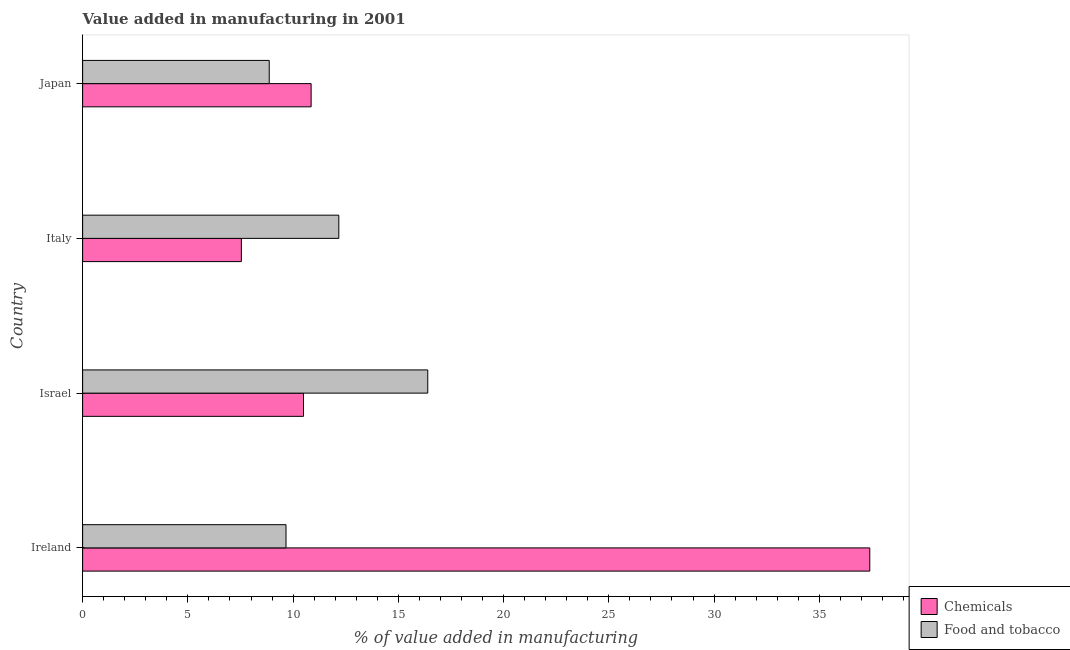How many different coloured bars are there?
Keep it short and to the point. 2. Are the number of bars per tick equal to the number of legend labels?
Your response must be concise. Yes. Are the number of bars on each tick of the Y-axis equal?
Keep it short and to the point. Yes. What is the label of the 1st group of bars from the top?
Provide a short and direct response. Japan. In how many cases, is the number of bars for a given country not equal to the number of legend labels?
Offer a very short reply. 0. What is the value added by  manufacturing chemicals in Ireland?
Ensure brevity in your answer.  37.4. Across all countries, what is the maximum value added by manufacturing food and tobacco?
Offer a terse response. 16.4. Across all countries, what is the minimum value added by manufacturing food and tobacco?
Make the answer very short. 8.87. What is the total value added by  manufacturing chemicals in the graph?
Provide a succinct answer. 66.29. What is the difference between the value added by  manufacturing chemicals in Ireland and that in Israel?
Provide a succinct answer. 26.9. What is the difference between the value added by manufacturing food and tobacco in Japan and the value added by  manufacturing chemicals in Italy?
Keep it short and to the point. 1.32. What is the average value added by  manufacturing chemicals per country?
Offer a very short reply. 16.57. What is the difference between the value added by  manufacturing chemicals and value added by manufacturing food and tobacco in Ireland?
Your answer should be compact. 27.73. In how many countries, is the value added by  manufacturing chemicals greater than 8 %?
Provide a short and direct response. 3. What is the ratio of the value added by  manufacturing chemicals in Ireland to that in Israel?
Ensure brevity in your answer.  3.56. Is the value added by  manufacturing chemicals in Ireland less than that in Japan?
Give a very brief answer. No. What is the difference between the highest and the second highest value added by manufacturing food and tobacco?
Give a very brief answer. 4.23. What is the difference between the highest and the lowest value added by manufacturing food and tobacco?
Provide a short and direct response. 7.53. In how many countries, is the value added by  manufacturing chemicals greater than the average value added by  manufacturing chemicals taken over all countries?
Make the answer very short. 1. What does the 2nd bar from the top in Italy represents?
Offer a terse response. Chemicals. What does the 1st bar from the bottom in Italy represents?
Your answer should be very brief. Chemicals. Are all the bars in the graph horizontal?
Ensure brevity in your answer.  Yes. How many countries are there in the graph?
Keep it short and to the point. 4. Are the values on the major ticks of X-axis written in scientific E-notation?
Offer a terse response. No. How many legend labels are there?
Your answer should be compact. 2. What is the title of the graph?
Your answer should be very brief. Value added in manufacturing in 2001. Does "Female labor force" appear as one of the legend labels in the graph?
Your answer should be compact. No. What is the label or title of the X-axis?
Make the answer very short. % of value added in manufacturing. What is the label or title of the Y-axis?
Offer a terse response. Country. What is the % of value added in manufacturing in Chemicals in Ireland?
Provide a succinct answer. 37.4. What is the % of value added in manufacturing of Food and tobacco in Ireland?
Provide a succinct answer. 9.66. What is the % of value added in manufacturing of Chemicals in Israel?
Keep it short and to the point. 10.49. What is the % of value added in manufacturing of Food and tobacco in Israel?
Offer a very short reply. 16.4. What is the % of value added in manufacturing of Chemicals in Italy?
Your answer should be very brief. 7.54. What is the % of value added in manufacturing of Food and tobacco in Italy?
Ensure brevity in your answer.  12.17. What is the % of value added in manufacturing of Chemicals in Japan?
Your answer should be very brief. 10.86. What is the % of value added in manufacturing of Food and tobacco in Japan?
Provide a succinct answer. 8.87. Across all countries, what is the maximum % of value added in manufacturing in Chemicals?
Give a very brief answer. 37.4. Across all countries, what is the maximum % of value added in manufacturing of Food and tobacco?
Ensure brevity in your answer.  16.4. Across all countries, what is the minimum % of value added in manufacturing in Chemicals?
Provide a short and direct response. 7.54. Across all countries, what is the minimum % of value added in manufacturing of Food and tobacco?
Ensure brevity in your answer.  8.87. What is the total % of value added in manufacturing in Chemicals in the graph?
Provide a short and direct response. 66.29. What is the total % of value added in manufacturing of Food and tobacco in the graph?
Provide a succinct answer. 47.1. What is the difference between the % of value added in manufacturing in Chemicals in Ireland and that in Israel?
Offer a very short reply. 26.9. What is the difference between the % of value added in manufacturing of Food and tobacco in Ireland and that in Israel?
Keep it short and to the point. -6.73. What is the difference between the % of value added in manufacturing of Chemicals in Ireland and that in Italy?
Ensure brevity in your answer.  29.86. What is the difference between the % of value added in manufacturing of Food and tobacco in Ireland and that in Italy?
Provide a short and direct response. -2.51. What is the difference between the % of value added in manufacturing of Chemicals in Ireland and that in Japan?
Provide a succinct answer. 26.54. What is the difference between the % of value added in manufacturing in Food and tobacco in Ireland and that in Japan?
Give a very brief answer. 0.8. What is the difference between the % of value added in manufacturing of Chemicals in Israel and that in Italy?
Offer a terse response. 2.95. What is the difference between the % of value added in manufacturing of Food and tobacco in Israel and that in Italy?
Offer a terse response. 4.23. What is the difference between the % of value added in manufacturing of Chemicals in Israel and that in Japan?
Offer a terse response. -0.36. What is the difference between the % of value added in manufacturing in Food and tobacco in Israel and that in Japan?
Give a very brief answer. 7.53. What is the difference between the % of value added in manufacturing of Chemicals in Italy and that in Japan?
Keep it short and to the point. -3.32. What is the difference between the % of value added in manufacturing of Food and tobacco in Italy and that in Japan?
Give a very brief answer. 3.31. What is the difference between the % of value added in manufacturing of Chemicals in Ireland and the % of value added in manufacturing of Food and tobacco in Israel?
Your answer should be very brief. 21. What is the difference between the % of value added in manufacturing of Chemicals in Ireland and the % of value added in manufacturing of Food and tobacco in Italy?
Your response must be concise. 25.23. What is the difference between the % of value added in manufacturing in Chemicals in Ireland and the % of value added in manufacturing in Food and tobacco in Japan?
Your answer should be very brief. 28.53. What is the difference between the % of value added in manufacturing of Chemicals in Israel and the % of value added in manufacturing of Food and tobacco in Italy?
Keep it short and to the point. -1.68. What is the difference between the % of value added in manufacturing in Chemicals in Israel and the % of value added in manufacturing in Food and tobacco in Japan?
Offer a very short reply. 1.63. What is the difference between the % of value added in manufacturing in Chemicals in Italy and the % of value added in manufacturing in Food and tobacco in Japan?
Give a very brief answer. -1.32. What is the average % of value added in manufacturing in Chemicals per country?
Your answer should be very brief. 16.57. What is the average % of value added in manufacturing of Food and tobacco per country?
Your answer should be compact. 11.77. What is the difference between the % of value added in manufacturing in Chemicals and % of value added in manufacturing in Food and tobacco in Ireland?
Give a very brief answer. 27.74. What is the difference between the % of value added in manufacturing of Chemicals and % of value added in manufacturing of Food and tobacco in Israel?
Provide a succinct answer. -5.9. What is the difference between the % of value added in manufacturing of Chemicals and % of value added in manufacturing of Food and tobacco in Italy?
Offer a very short reply. -4.63. What is the difference between the % of value added in manufacturing in Chemicals and % of value added in manufacturing in Food and tobacco in Japan?
Your response must be concise. 1.99. What is the ratio of the % of value added in manufacturing in Chemicals in Ireland to that in Israel?
Make the answer very short. 3.56. What is the ratio of the % of value added in manufacturing of Food and tobacco in Ireland to that in Israel?
Provide a short and direct response. 0.59. What is the ratio of the % of value added in manufacturing in Chemicals in Ireland to that in Italy?
Offer a terse response. 4.96. What is the ratio of the % of value added in manufacturing in Food and tobacco in Ireland to that in Italy?
Your response must be concise. 0.79. What is the ratio of the % of value added in manufacturing of Chemicals in Ireland to that in Japan?
Ensure brevity in your answer.  3.44. What is the ratio of the % of value added in manufacturing of Food and tobacco in Ireland to that in Japan?
Make the answer very short. 1.09. What is the ratio of the % of value added in manufacturing in Chemicals in Israel to that in Italy?
Make the answer very short. 1.39. What is the ratio of the % of value added in manufacturing of Food and tobacco in Israel to that in Italy?
Keep it short and to the point. 1.35. What is the ratio of the % of value added in manufacturing in Chemicals in Israel to that in Japan?
Your response must be concise. 0.97. What is the ratio of the % of value added in manufacturing in Food and tobacco in Israel to that in Japan?
Provide a short and direct response. 1.85. What is the ratio of the % of value added in manufacturing of Chemicals in Italy to that in Japan?
Ensure brevity in your answer.  0.69. What is the ratio of the % of value added in manufacturing of Food and tobacco in Italy to that in Japan?
Give a very brief answer. 1.37. What is the difference between the highest and the second highest % of value added in manufacturing in Chemicals?
Your answer should be compact. 26.54. What is the difference between the highest and the second highest % of value added in manufacturing of Food and tobacco?
Offer a very short reply. 4.23. What is the difference between the highest and the lowest % of value added in manufacturing in Chemicals?
Make the answer very short. 29.86. What is the difference between the highest and the lowest % of value added in manufacturing of Food and tobacco?
Give a very brief answer. 7.53. 